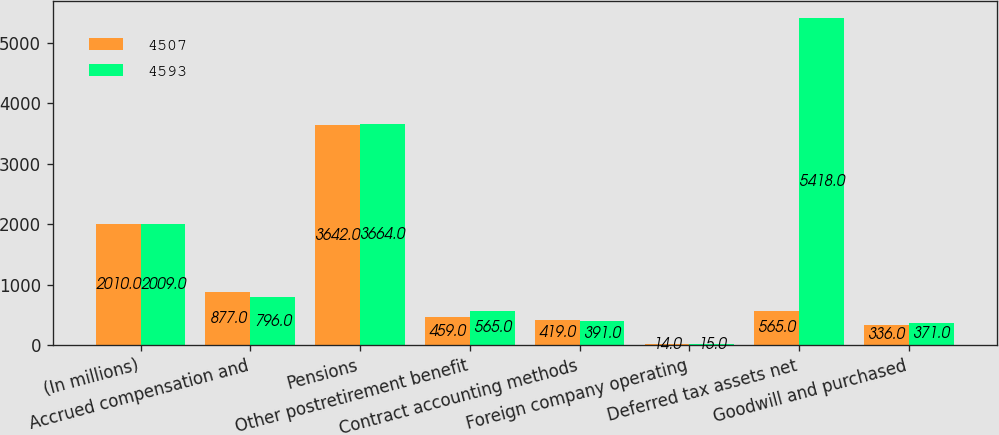Convert chart. <chart><loc_0><loc_0><loc_500><loc_500><stacked_bar_chart><ecel><fcel>(In millions)<fcel>Accrued compensation and<fcel>Pensions<fcel>Other postretirement benefit<fcel>Contract accounting methods<fcel>Foreign company operating<fcel>Deferred tax assets net<fcel>Goodwill and purchased<nl><fcel>4507<fcel>2010<fcel>877<fcel>3642<fcel>459<fcel>419<fcel>14<fcel>565<fcel>336<nl><fcel>4593<fcel>2009<fcel>796<fcel>3664<fcel>565<fcel>391<fcel>15<fcel>5418<fcel>371<nl></chart> 